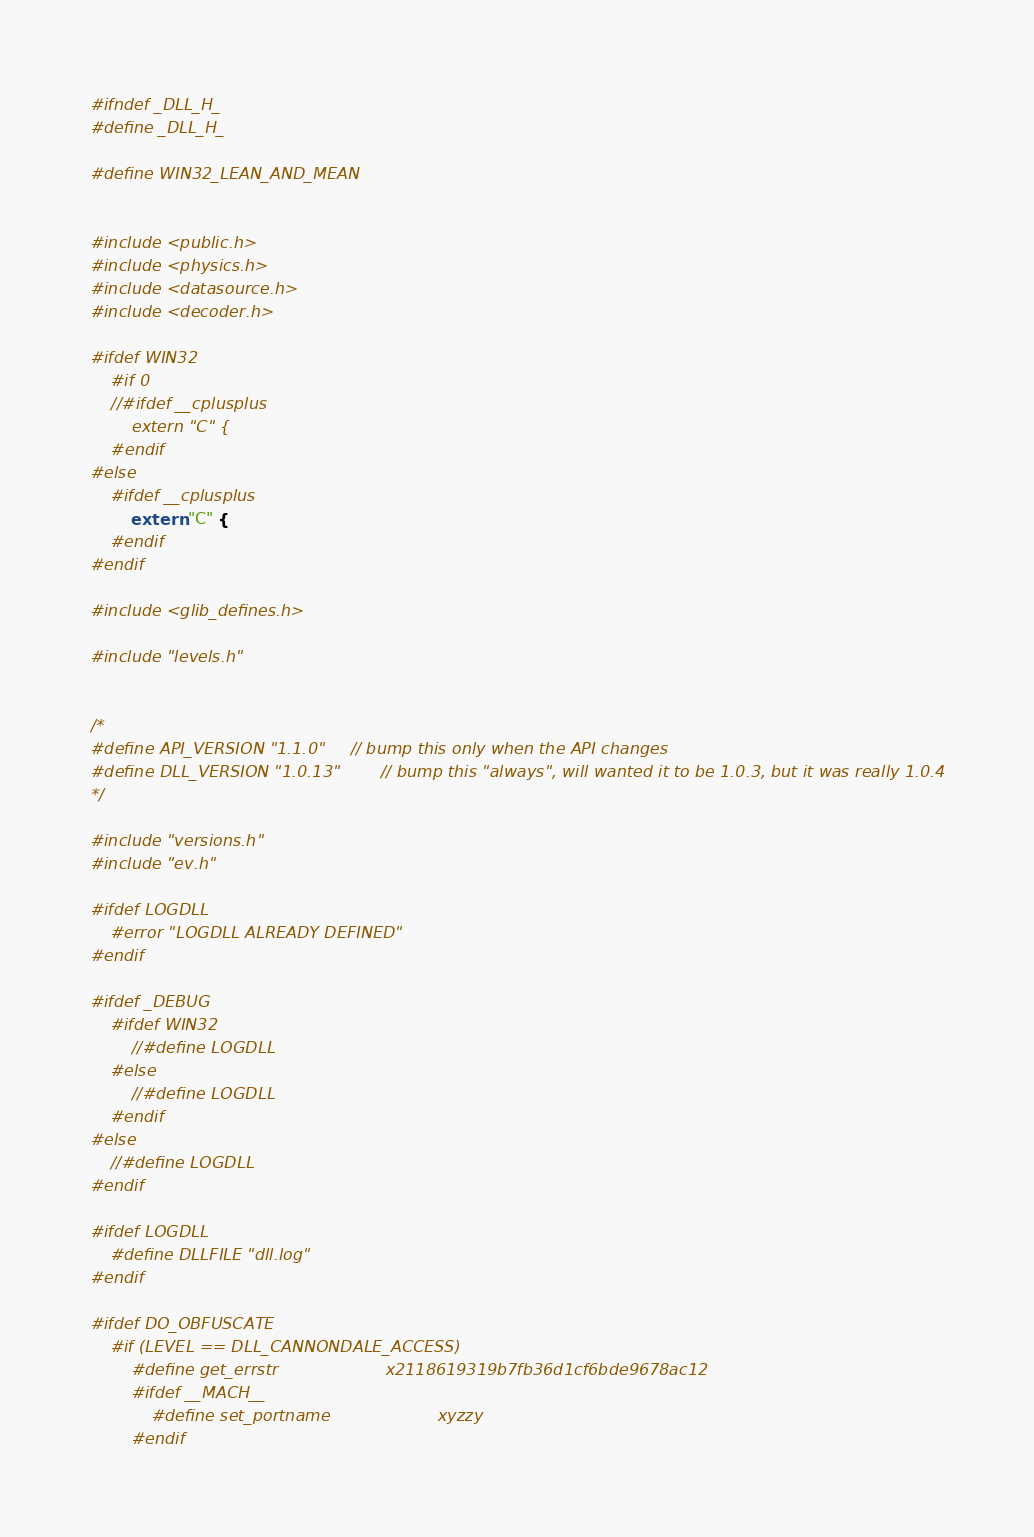Convert code to text. <code><loc_0><loc_0><loc_500><loc_500><_C_>#ifndef _DLL_H_
#define _DLL_H_

#define WIN32_LEAN_AND_MEAN


#include <public.h>
#include <physics.h>
#include <datasource.h>
#include <decoder.h>

#ifdef WIN32
	#if 0
	//#ifdef __cplusplus
		extern "C" {
	#endif
#else
	#ifdef __cplusplus
		extern "C" {
	#endif
#endif

#include <glib_defines.h>

#include "levels.h"


/*
#define API_VERSION "1.1.0"		// bump this only when the API changes
#define DLL_VERSION "1.0.13"		// bump this "always", will wanted it to be 1.0.3, but it was really 1.0.4
*/

#include "versions.h"
#include "ev.h"

#ifdef LOGDLL
	#error "LOGDLL ALREADY DEFINED"
#endif

#ifdef _DEBUG
	#ifdef WIN32
		//#define LOGDLL
	#else
		//#define LOGDLL
	#endif
#else
	//#define LOGDLL
#endif

#ifdef LOGDLL
	#define DLLFILE "dll.log"
#endif

#ifdef DO_OBFUSCATE
	#if (LEVEL == DLL_CANNONDALE_ACCESS)
		#define get_errstr                     x2118619319b7fb36d1cf6bde9678ac12
		#ifdef __MACH__
			#define set_portname						xyzzy
		#endif
</code> 